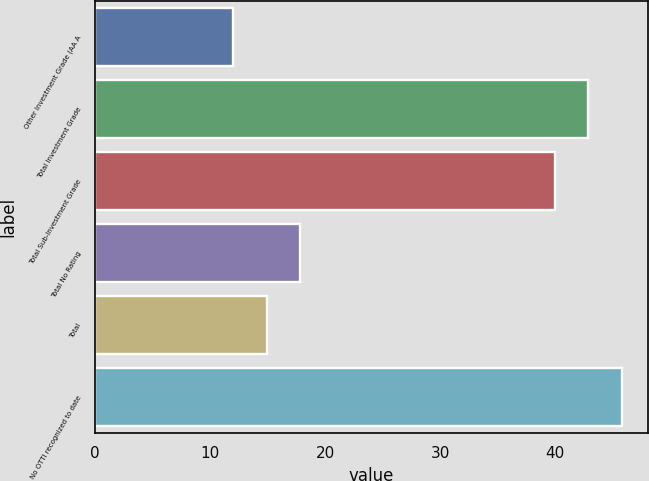<chart> <loc_0><loc_0><loc_500><loc_500><bar_chart><fcel>Other Investment Grade (AA A<fcel>Total Investment Grade<fcel>Total Sub-Investment Grade<fcel>Total No Rating<fcel>Total<fcel>No OTTI recognized to date<nl><fcel>12<fcel>42.9<fcel>40<fcel>17.8<fcel>14.9<fcel>45.8<nl></chart> 